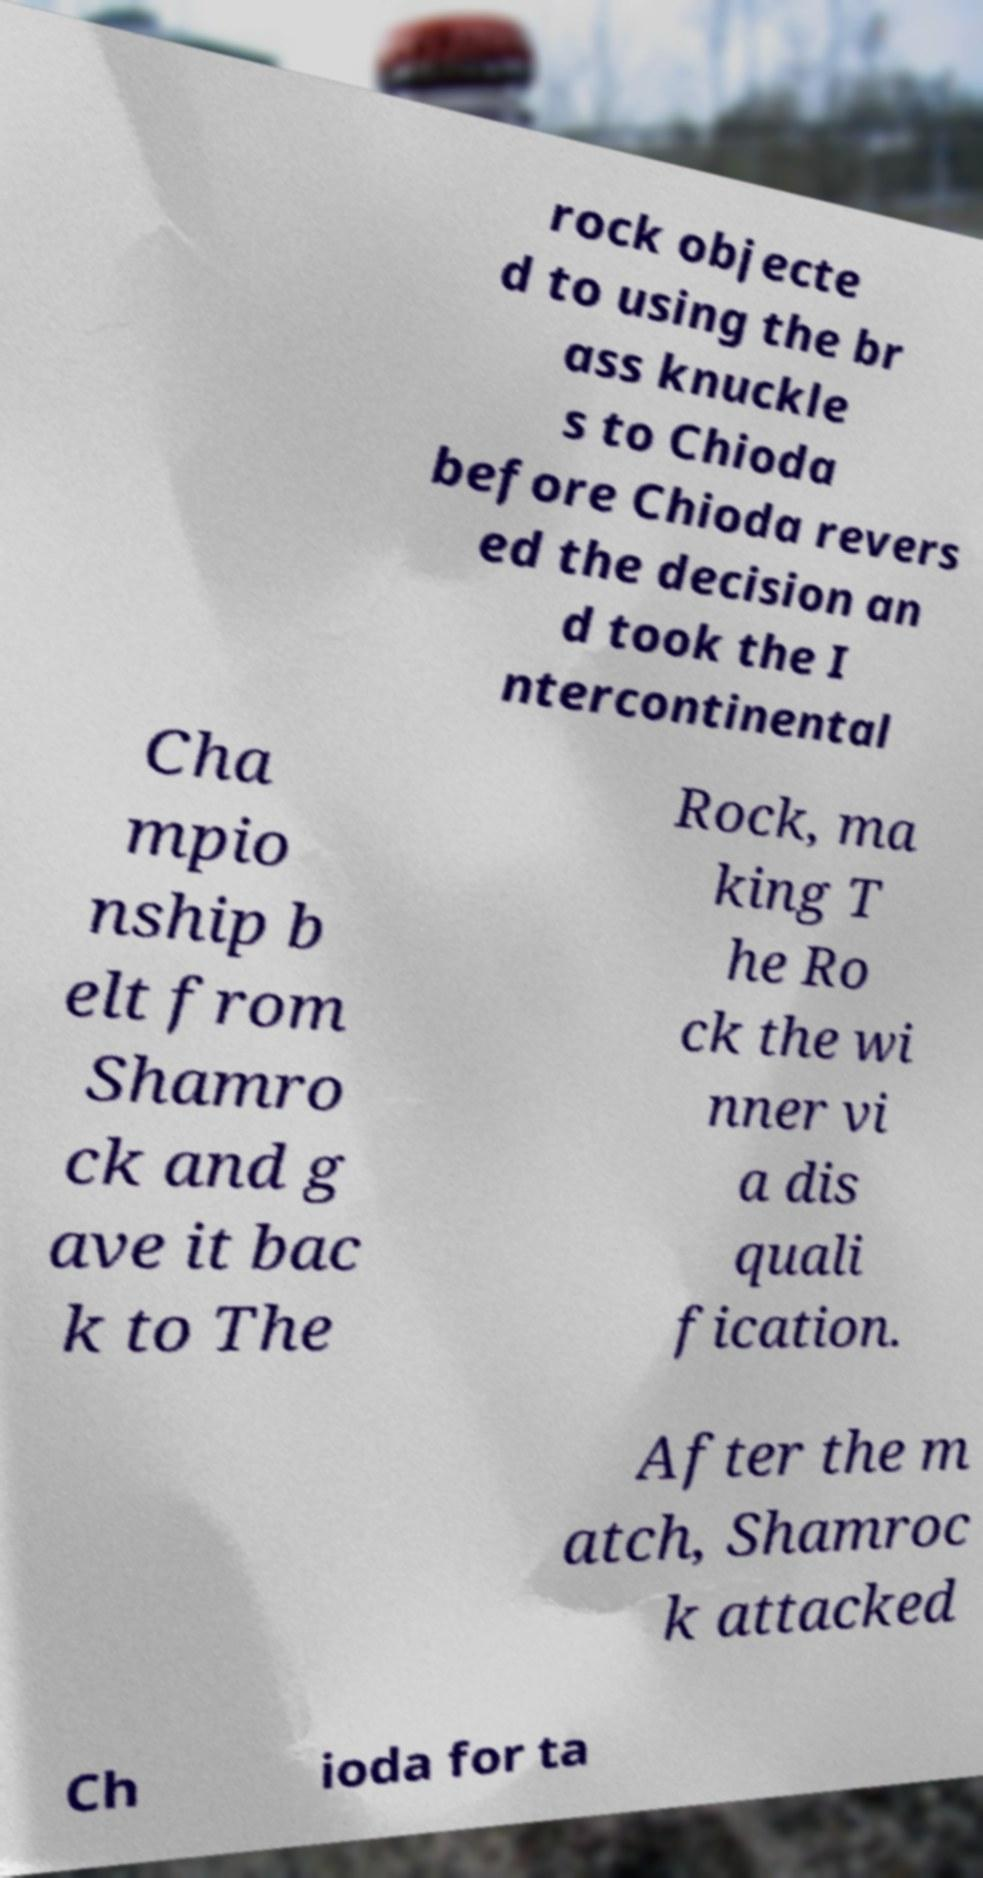There's text embedded in this image that I need extracted. Can you transcribe it verbatim? rock objecte d to using the br ass knuckle s to Chioda before Chioda revers ed the decision an d took the I ntercontinental Cha mpio nship b elt from Shamro ck and g ave it bac k to The Rock, ma king T he Ro ck the wi nner vi a dis quali fication. After the m atch, Shamroc k attacked Ch ioda for ta 